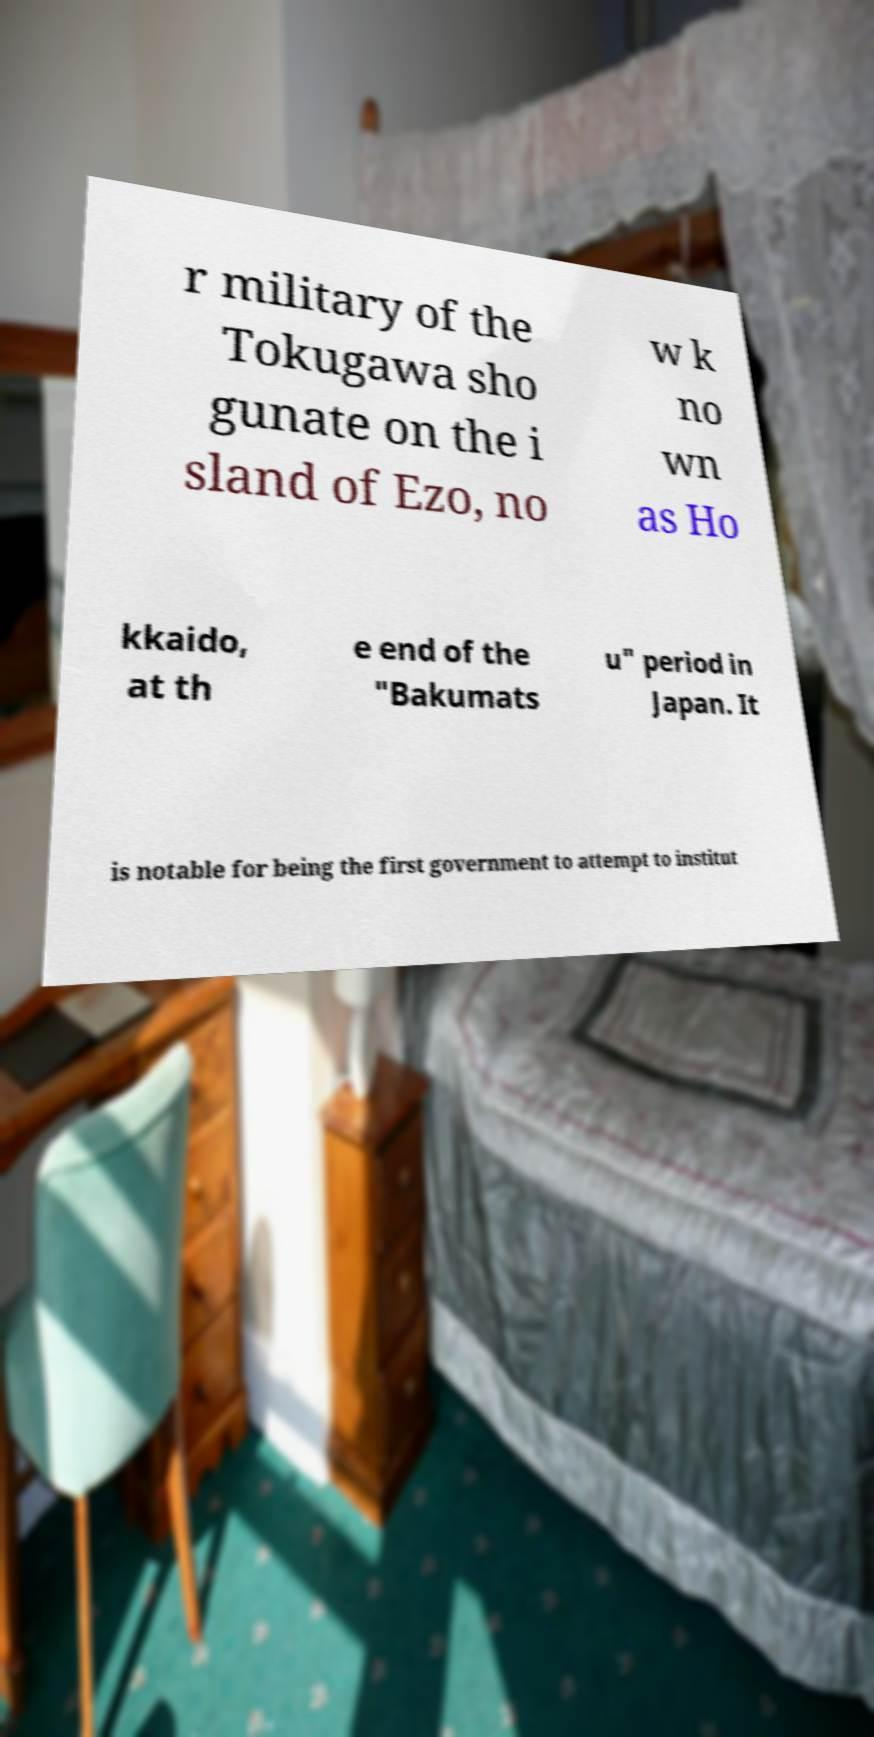Please identify and transcribe the text found in this image. r military of the Tokugawa sho gunate on the i sland of Ezo, no w k no wn as Ho kkaido, at th e end of the "Bakumats u" period in Japan. It is notable for being the first government to attempt to institut 